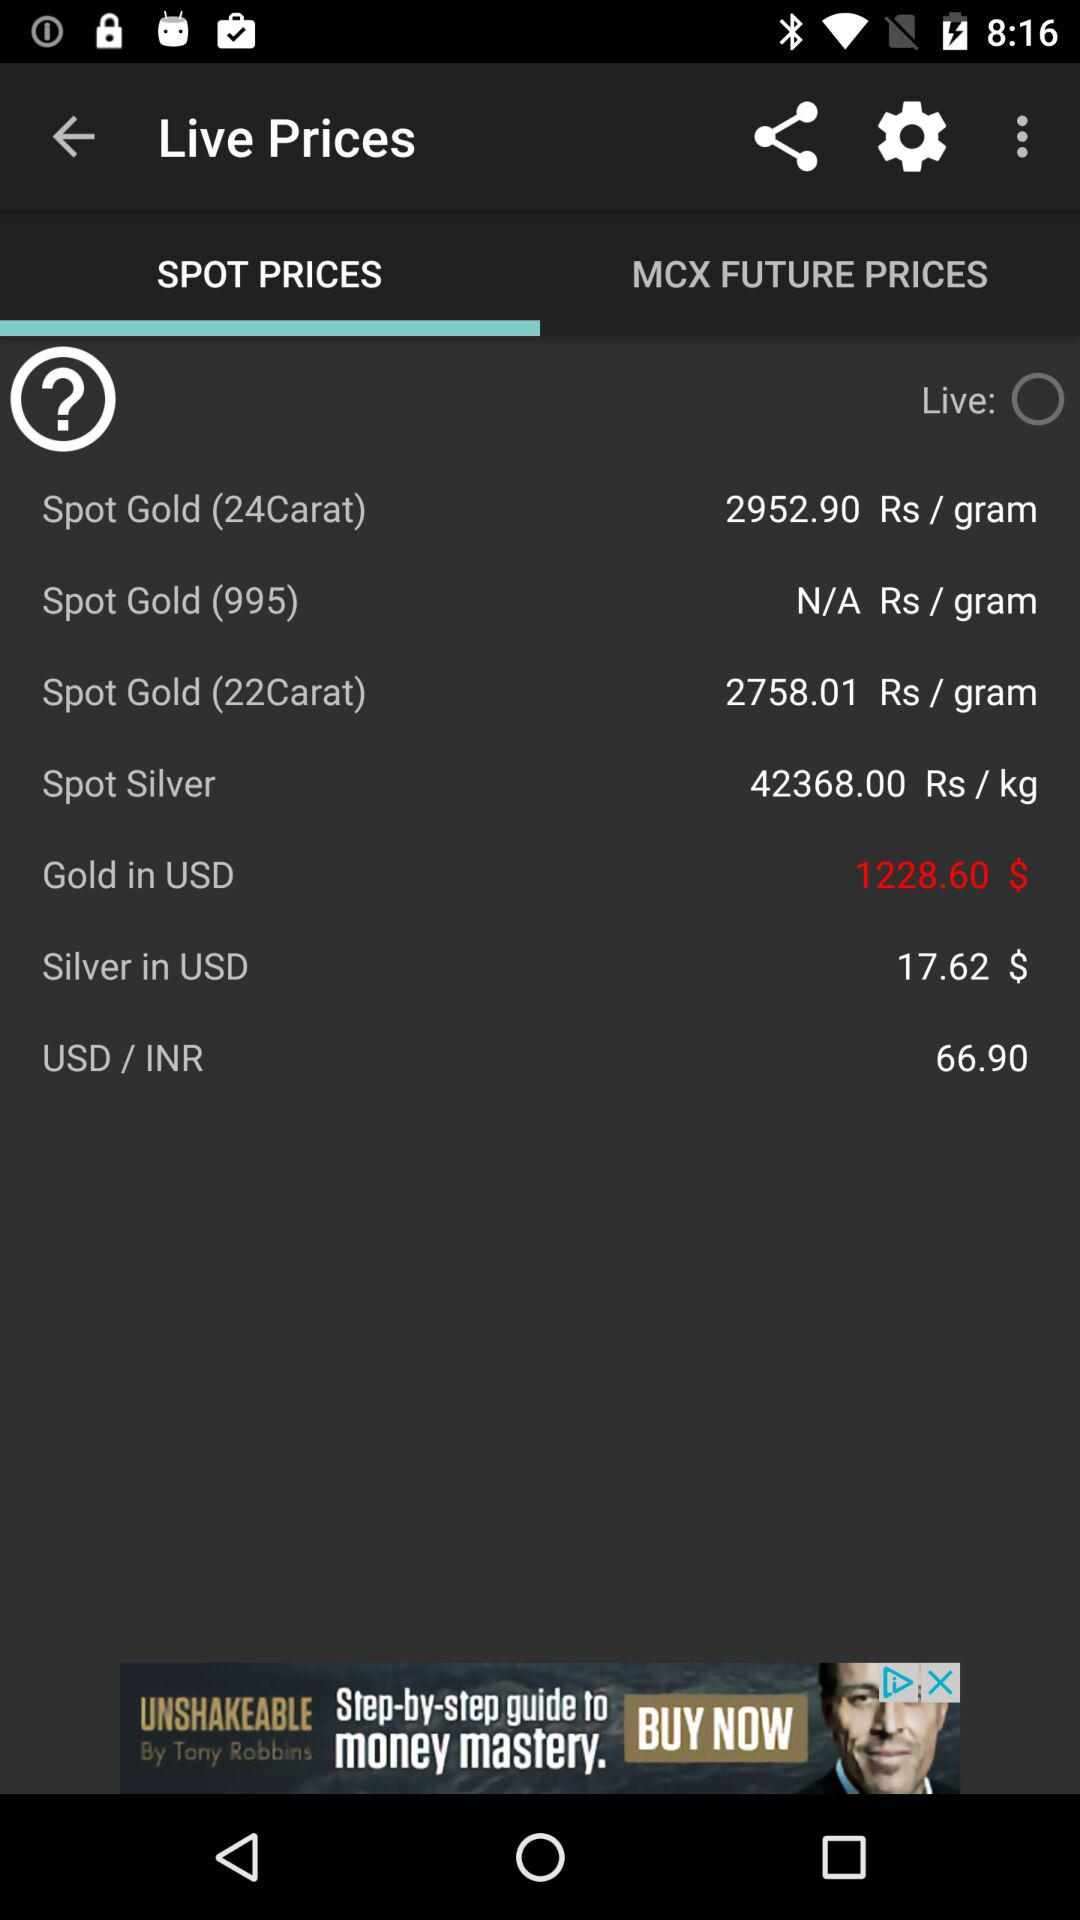What is the spot price of "Silver" per kg? The spot price of "Silver" is Rs 42368 per kg. 